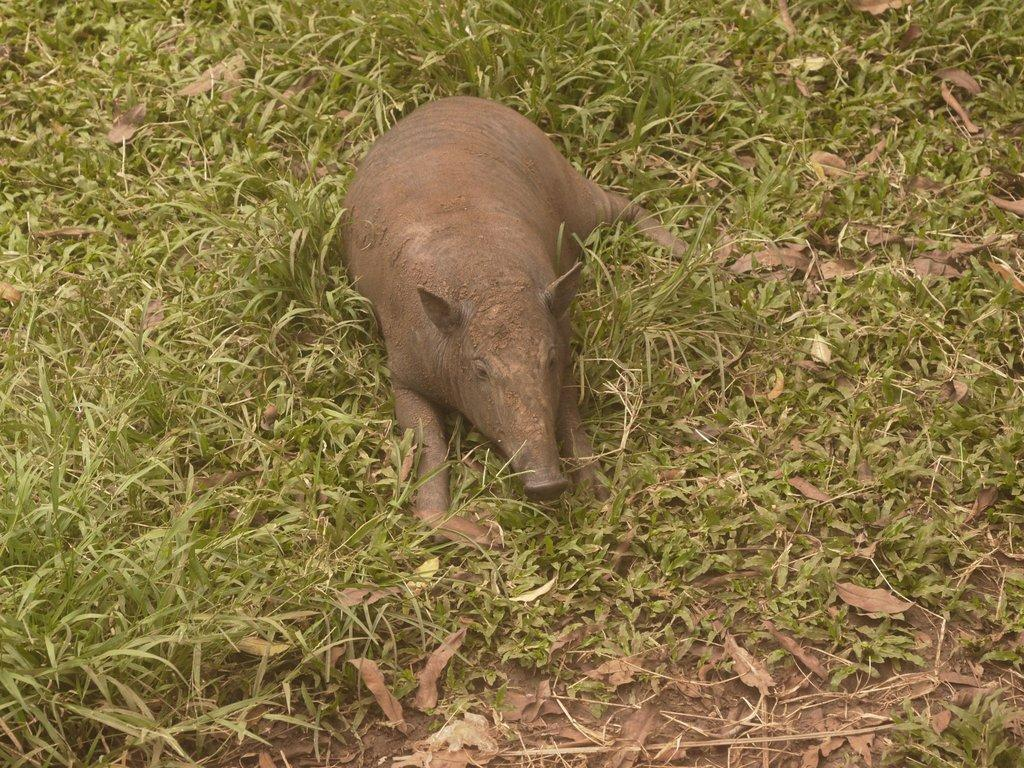What animal is the main subject of the picture? There is a pig in the picture. Where is the pig located in the image? The pig is sitting on the grass. What type of vegetation can be seen at the bottom of the image? Leaves are visible at the bottom of the image. What type of trouble is the pig causing in the image? There is no indication of trouble or any problematic behavior in the image; the pig is simply sitting on the grass. 